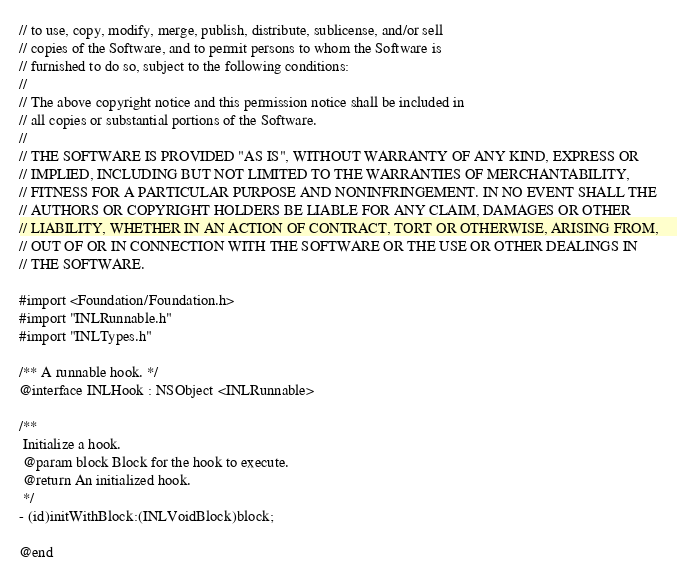<code> <loc_0><loc_0><loc_500><loc_500><_C_>// to use, copy, modify, merge, publish, distribute, sublicense, and/or sell
// copies of the Software, and to permit persons to whom the Software is
// furnished to do so, subject to the following conditions:
//
// The above copyright notice and this permission notice shall be included in
// all copies or substantial portions of the Software.
//
// THE SOFTWARE IS PROVIDED "AS IS", WITHOUT WARRANTY OF ANY KIND, EXPRESS OR
// IMPLIED, INCLUDING BUT NOT LIMITED TO THE WARRANTIES OF MERCHANTABILITY,
// FITNESS FOR A PARTICULAR PURPOSE AND NONINFRINGEMENT. IN NO EVENT SHALL THE
// AUTHORS OR COPYRIGHT HOLDERS BE LIABLE FOR ANY CLAIM, DAMAGES OR OTHER
// LIABILITY, WHETHER IN AN ACTION OF CONTRACT, TORT OR OTHERWISE, ARISING FROM,
// OUT OF OR IN CONNECTION WITH THE SOFTWARE OR THE USE OR OTHER DEALINGS IN
// THE SOFTWARE.

#import <Foundation/Foundation.h>
#import "INLRunnable.h"
#import "INLTypes.h"

/** A runnable hook. */
@interface INLHook : NSObject <INLRunnable>

/**
 Initialize a hook.
 @param block Block for the hook to execute.
 @return An initialized hook.
 */
- (id)initWithBlock:(INLVoidBlock)block;

@end
</code> 